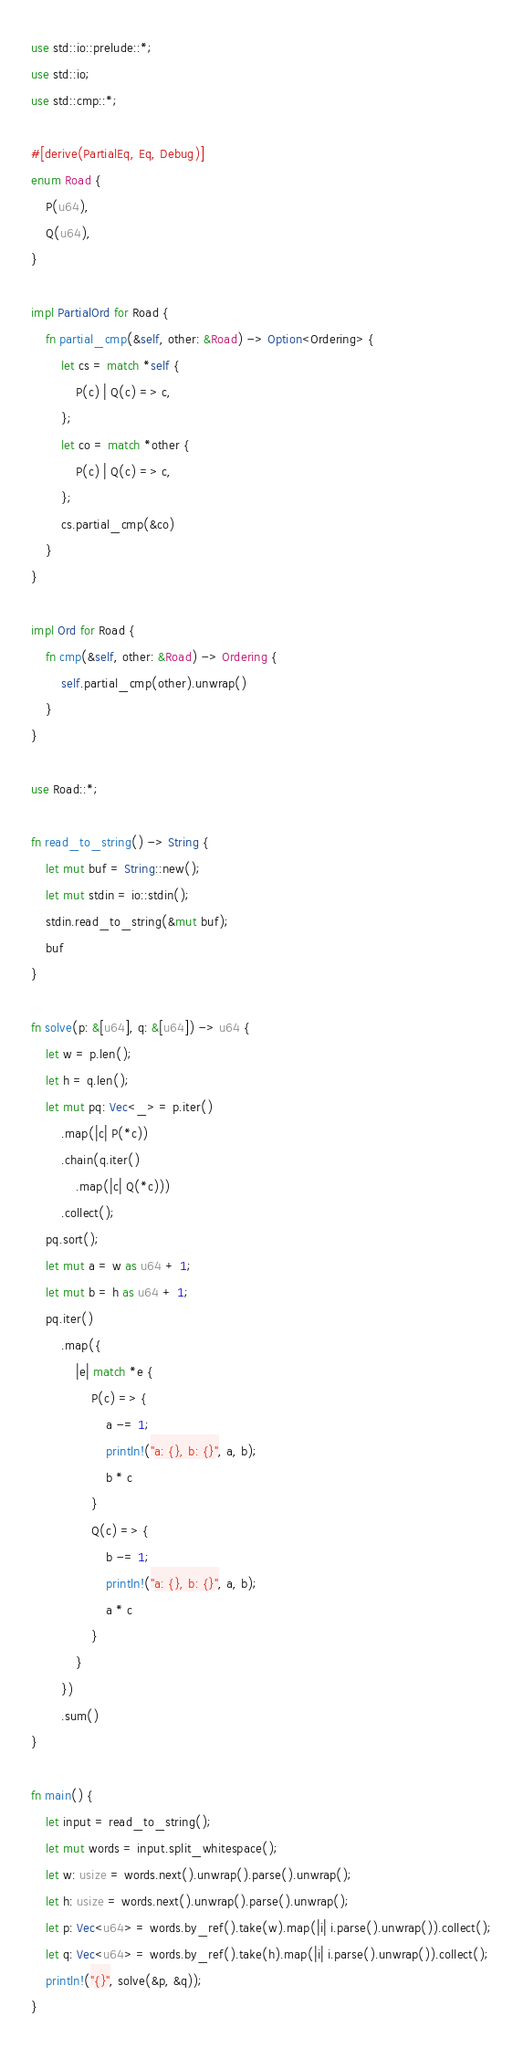Convert code to text. <code><loc_0><loc_0><loc_500><loc_500><_Rust_>use std::io::prelude::*;
use std::io;
use std::cmp::*;

#[derive(PartialEq, Eq, Debug)]
enum Road {
    P(u64),
    Q(u64),
}

impl PartialOrd for Road {
    fn partial_cmp(&self, other: &Road) -> Option<Ordering> {
        let cs = match *self {
            P(c) | Q(c) => c,
        };
        let co = match *other {
            P(c) | Q(c) => c,
        };
        cs.partial_cmp(&co)
    }
}

impl Ord for Road {
    fn cmp(&self, other: &Road) -> Ordering {
        self.partial_cmp(other).unwrap()
    }
}

use Road::*;

fn read_to_string() -> String {
    let mut buf = String::new();
    let mut stdin = io::stdin();
    stdin.read_to_string(&mut buf);
    buf
}

fn solve(p: &[u64], q: &[u64]) -> u64 {
    let w = p.len();
    let h = q.len();
    let mut pq: Vec<_> = p.iter()
        .map(|c| P(*c))
        .chain(q.iter()
            .map(|c| Q(*c)))
        .collect();
    pq.sort();
    let mut a = w as u64 + 1;
    let mut b = h as u64 + 1;
    pq.iter()
        .map({
            |e| match *e {
                P(c) => {
                    a -= 1;
                    println!("a: {}, b: {}", a, b);
                    b * c
                }
                Q(c) => {
                    b -= 1;
                    println!("a: {}, b: {}", a, b);
                    a * c
                }
            }
        })
        .sum()
}

fn main() {
    let input = read_to_string();
    let mut words = input.split_whitespace();
    let w: usize = words.next().unwrap().parse().unwrap();
    let h: usize = words.next().unwrap().parse().unwrap();
    let p: Vec<u64> = words.by_ref().take(w).map(|i| i.parse().unwrap()).collect();
    let q: Vec<u64> = words.by_ref().take(h).map(|i| i.parse().unwrap()).collect();
    println!("{}", solve(&p, &q));
}
</code> 